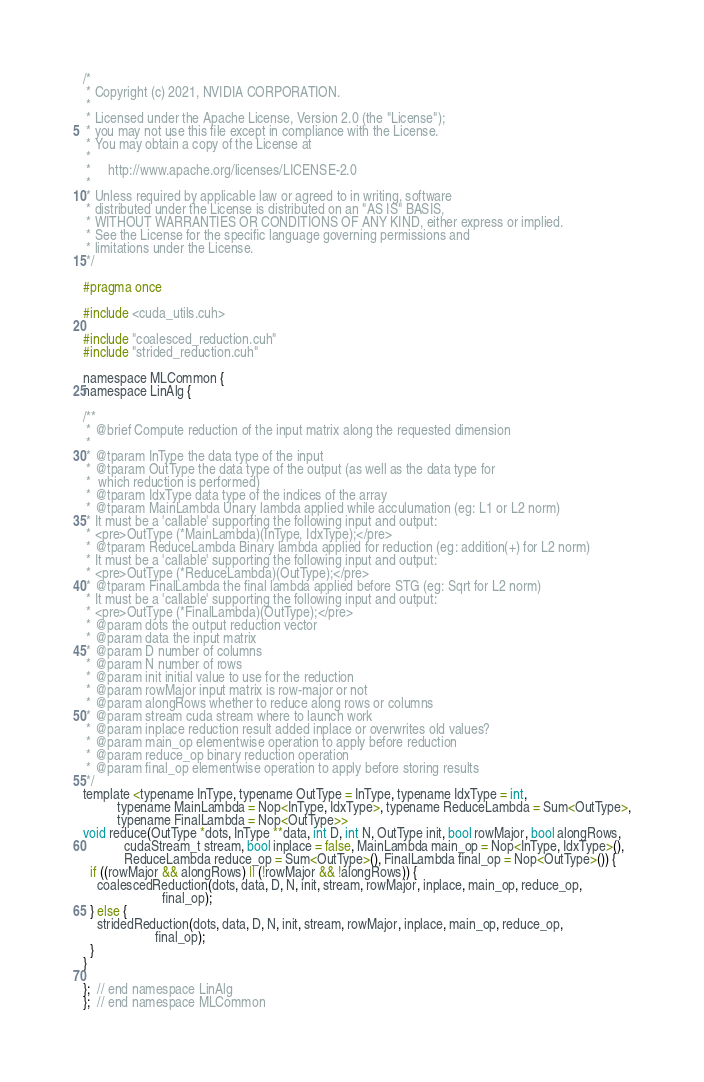<code> <loc_0><loc_0><loc_500><loc_500><_Cuda_>/*
 * Copyright (c) 2021, NVIDIA CORPORATION.
 *
 * Licensed under the Apache License, Version 2.0 (the "License");
 * you may not use this file except in compliance with the License.
 * You may obtain a copy of the License at
 *
 *     http://www.apache.org/licenses/LICENSE-2.0
 *
 * Unless required by applicable law or agreed to in writing, software
 * distributed under the License is distributed on an "AS IS" BASIS,
 * WITHOUT WARRANTIES OR CONDITIONS OF ANY KIND, either express or implied.
 * See the License for the specific language governing permissions and
 * limitations under the License.
 */

#pragma once

#include <cuda_utils.cuh>

#include "coalesced_reduction.cuh"
#include "strided_reduction.cuh"

namespace MLCommon {
namespace LinAlg {

/**
 * @brief Compute reduction of the input matrix along the requested dimension
 *
 * @tparam InType the data type of the input
 * @tparam OutType the data type of the output (as well as the data type for
 *  which reduction is performed)
 * @tparam IdxType data type of the indices of the array
 * @tparam MainLambda Unary lambda applied while acculumation (eg: L1 or L2 norm)
 * It must be a 'callable' supporting the following input and output:
 * <pre>OutType (*MainLambda)(InType, IdxType);</pre>
 * @tparam ReduceLambda Binary lambda applied for reduction (eg: addition(+) for L2 norm)
 * It must be a 'callable' supporting the following input and output:
 * <pre>OutType (*ReduceLambda)(OutType);</pre>
 * @tparam FinalLambda the final lambda applied before STG (eg: Sqrt for L2 norm)
 * It must be a 'callable' supporting the following input and output:
 * <pre>OutType (*FinalLambda)(OutType);</pre>
 * @param dots the output reduction vector
 * @param data the input matrix
 * @param D number of columns
 * @param N number of rows
 * @param init initial value to use for the reduction
 * @param rowMajor input matrix is row-major or not
 * @param alongRows whether to reduce along rows or columns
 * @param stream cuda stream where to launch work
 * @param inplace reduction result added inplace or overwrites old values?
 * @param main_op elementwise operation to apply before reduction
 * @param reduce_op binary reduction operation
 * @param final_op elementwise operation to apply before storing results
 */
template <typename InType, typename OutType = InType, typename IdxType = int,
          typename MainLambda = Nop<InType, IdxType>, typename ReduceLambda = Sum<OutType>,
          typename FinalLambda = Nop<OutType>>
void reduce(OutType *dots, InType **data, int D, int N, OutType init, bool rowMajor, bool alongRows,
            cudaStream_t stream, bool inplace = false, MainLambda main_op = Nop<InType, IdxType>(),
            ReduceLambda reduce_op = Sum<OutType>(), FinalLambda final_op = Nop<OutType>()) {
  if ((rowMajor && alongRows) || (!rowMajor && !alongRows)) {
    coalescedReduction(dots, data, D, N, init, stream, rowMajor, inplace, main_op, reduce_op,
                       final_op);
  } else {
    stridedReduction(dots, data, D, N, init, stream, rowMajor, inplace, main_op, reduce_op,
                     final_op);
  }
}

};  // end namespace LinAlg
};  // end namespace MLCommon
</code> 